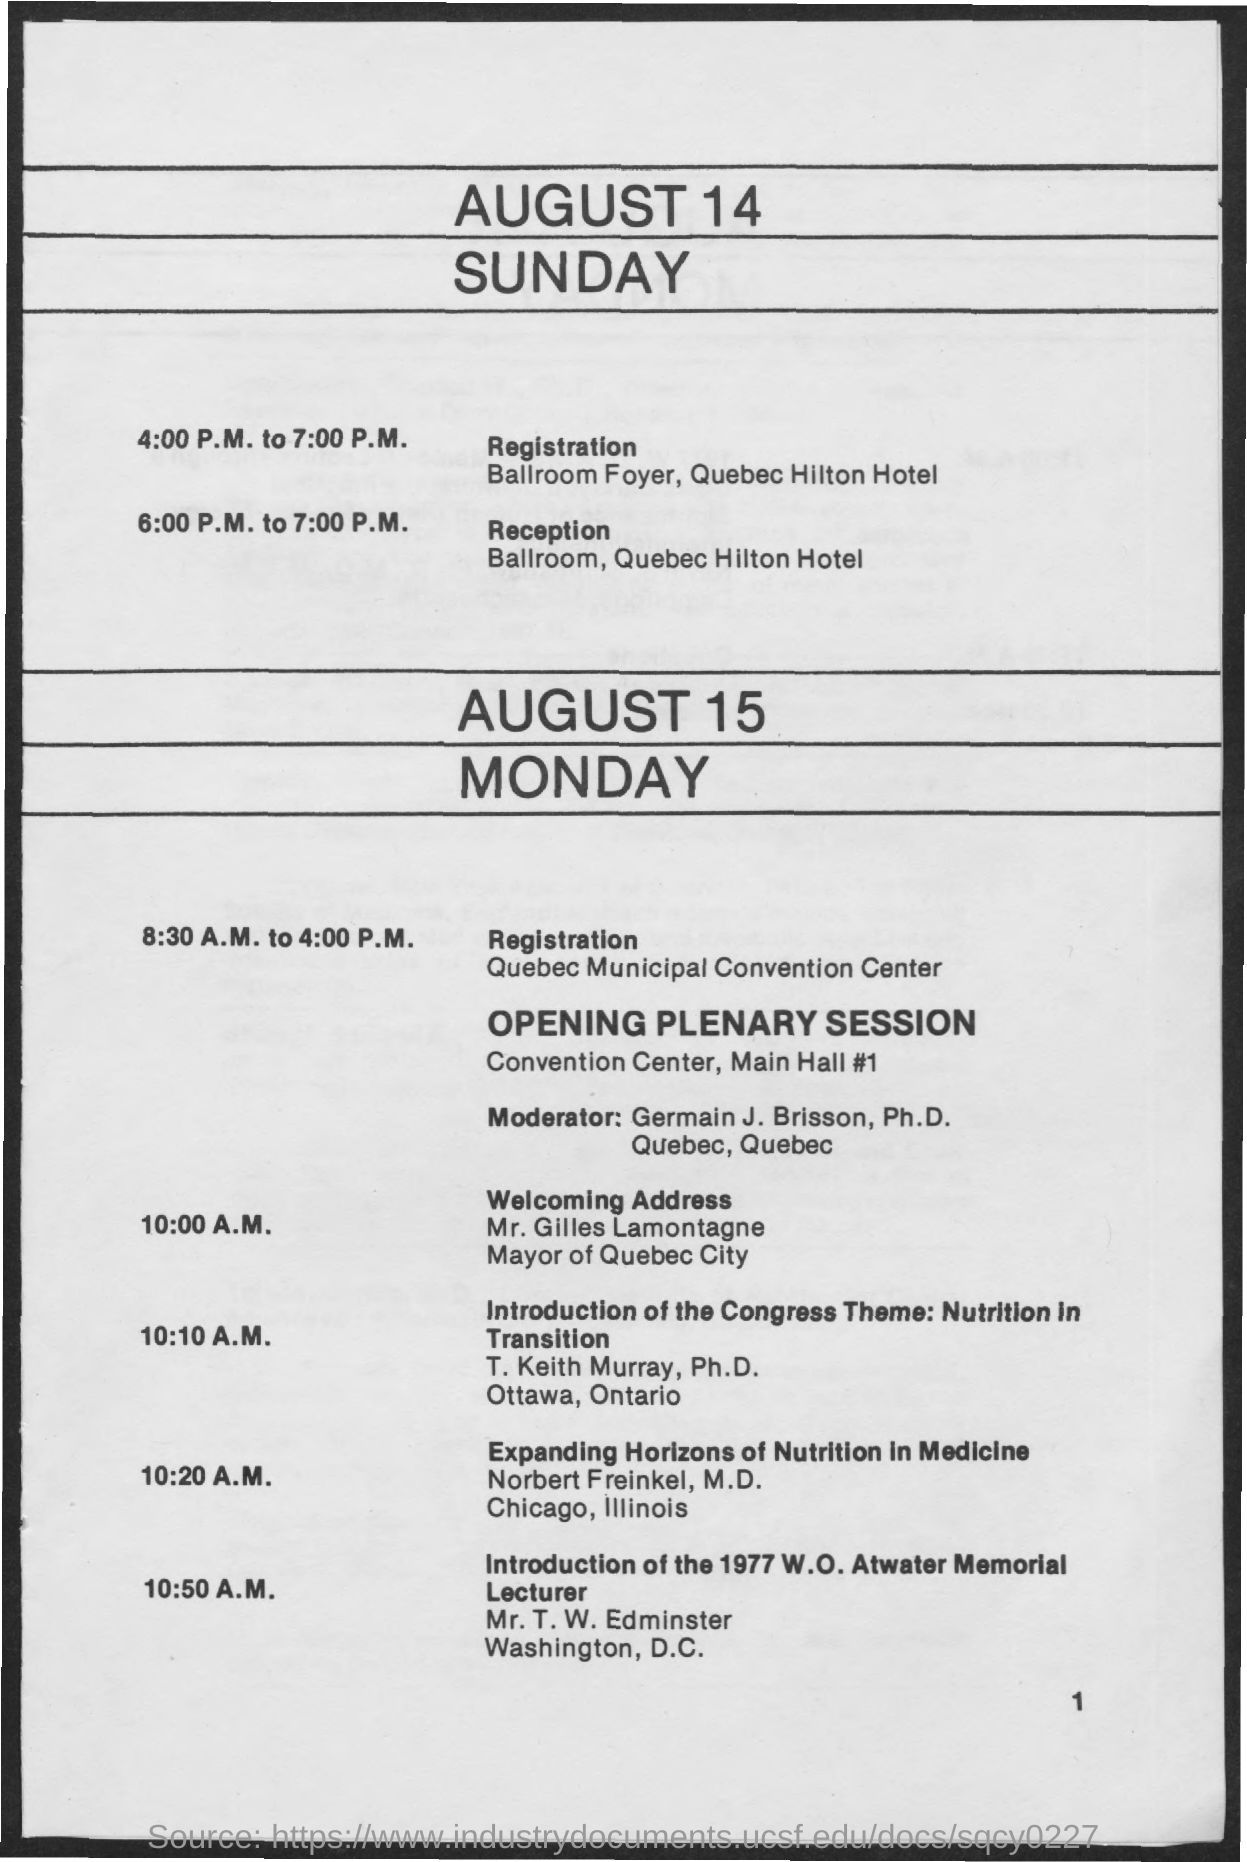What is venue for registration on august 14, sunday?
Ensure brevity in your answer.  Ballroom Foyer, Quebec Hilton Hotel. What is the venue for reception on august 14, sunday?
Make the answer very short. Ballroom, Quebec Hilton Hotel. What are timings scheduled for registration on august 14, sunday?
Provide a short and direct response. 4:00 P.M. to 7:00 P.M. What are timings scheduled for reception on august 14, sunday?
Ensure brevity in your answer.  6:00 P.M. to 7:00 P.M. Who is the mayor of quebec city?
Your answer should be very brief. Mr. Gilles Lamontagne. Discussion on Expanding Horizons of Nutrition in Medicine is given by?
Your answer should be compact. Nobert Freinkel,  M.D. What place is nobert freinkel from?
Give a very brief answer. Chicago, Illinois. 